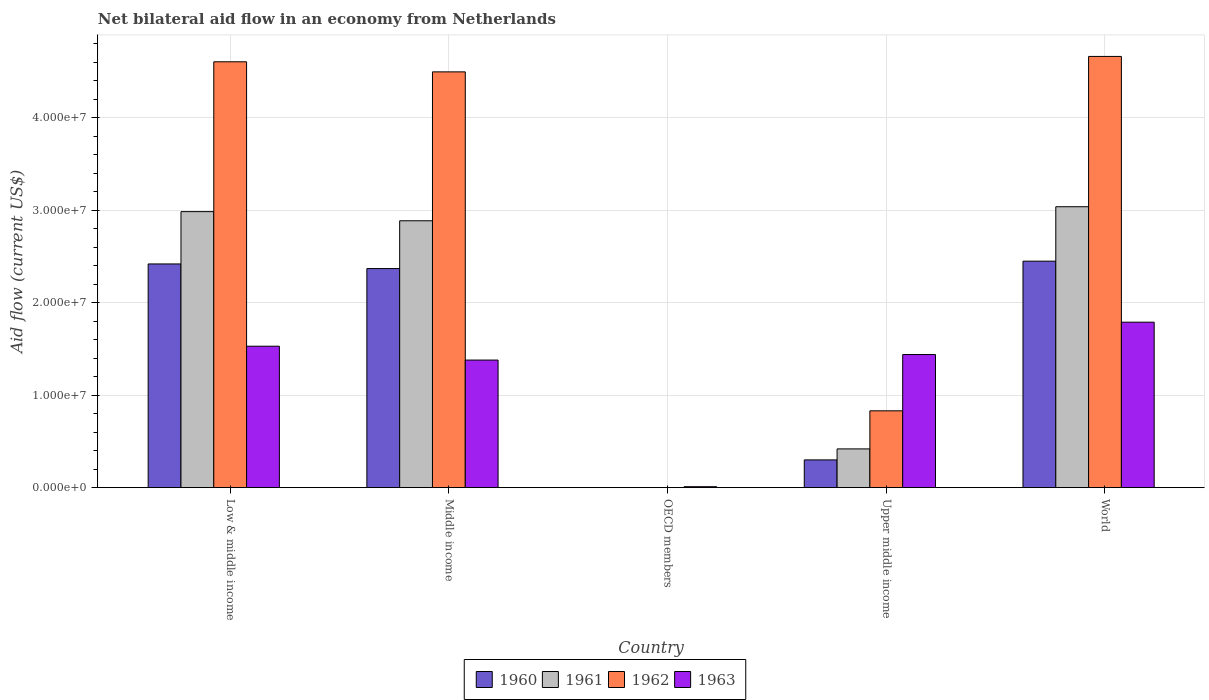Are the number of bars per tick equal to the number of legend labels?
Ensure brevity in your answer.  No. Are the number of bars on each tick of the X-axis equal?
Keep it short and to the point. No. How many bars are there on the 5th tick from the right?
Your response must be concise. 4. What is the label of the 2nd group of bars from the left?
Make the answer very short. Middle income. What is the net bilateral aid flow in 1960 in World?
Your answer should be compact. 2.45e+07. Across all countries, what is the maximum net bilateral aid flow in 1961?
Give a very brief answer. 3.04e+07. What is the total net bilateral aid flow in 1960 in the graph?
Offer a very short reply. 7.54e+07. What is the difference between the net bilateral aid flow in 1963 in OECD members and that in World?
Provide a short and direct response. -1.78e+07. What is the difference between the net bilateral aid flow in 1961 in Low & middle income and the net bilateral aid flow in 1962 in Middle income?
Make the answer very short. -1.51e+07. What is the average net bilateral aid flow in 1962 per country?
Your answer should be compact. 2.92e+07. What is the difference between the net bilateral aid flow of/in 1961 and net bilateral aid flow of/in 1960 in Middle income?
Your answer should be very brief. 5.17e+06. In how many countries, is the net bilateral aid flow in 1963 greater than 6000000 US$?
Offer a very short reply. 4. What is the ratio of the net bilateral aid flow in 1962 in Low & middle income to that in World?
Offer a very short reply. 0.99. Is the net bilateral aid flow in 1961 in Middle income less than that in World?
Give a very brief answer. Yes. What is the difference between the highest and the lowest net bilateral aid flow in 1962?
Your response must be concise. 4.66e+07. Is it the case that in every country, the sum of the net bilateral aid flow in 1960 and net bilateral aid flow in 1963 is greater than the net bilateral aid flow in 1962?
Provide a succinct answer. No. What is the difference between two consecutive major ticks on the Y-axis?
Your response must be concise. 1.00e+07. Does the graph contain any zero values?
Your answer should be compact. Yes. Does the graph contain grids?
Ensure brevity in your answer.  Yes. How many legend labels are there?
Make the answer very short. 4. What is the title of the graph?
Keep it short and to the point. Net bilateral aid flow in an economy from Netherlands. What is the Aid flow (current US$) in 1960 in Low & middle income?
Your answer should be very brief. 2.42e+07. What is the Aid flow (current US$) of 1961 in Low & middle income?
Ensure brevity in your answer.  2.99e+07. What is the Aid flow (current US$) of 1962 in Low & middle income?
Offer a terse response. 4.61e+07. What is the Aid flow (current US$) of 1963 in Low & middle income?
Make the answer very short. 1.53e+07. What is the Aid flow (current US$) of 1960 in Middle income?
Offer a terse response. 2.37e+07. What is the Aid flow (current US$) of 1961 in Middle income?
Give a very brief answer. 2.89e+07. What is the Aid flow (current US$) of 1962 in Middle income?
Offer a very short reply. 4.50e+07. What is the Aid flow (current US$) in 1963 in Middle income?
Provide a succinct answer. 1.38e+07. What is the Aid flow (current US$) of 1961 in OECD members?
Offer a terse response. 0. What is the Aid flow (current US$) of 1963 in OECD members?
Your response must be concise. 1.00e+05. What is the Aid flow (current US$) in 1960 in Upper middle income?
Your answer should be very brief. 3.00e+06. What is the Aid flow (current US$) in 1961 in Upper middle income?
Offer a terse response. 4.19e+06. What is the Aid flow (current US$) in 1962 in Upper middle income?
Keep it short and to the point. 8.31e+06. What is the Aid flow (current US$) in 1963 in Upper middle income?
Give a very brief answer. 1.44e+07. What is the Aid flow (current US$) in 1960 in World?
Your answer should be compact. 2.45e+07. What is the Aid flow (current US$) in 1961 in World?
Your answer should be compact. 3.04e+07. What is the Aid flow (current US$) in 1962 in World?
Your answer should be very brief. 4.66e+07. What is the Aid flow (current US$) of 1963 in World?
Your answer should be very brief. 1.79e+07. Across all countries, what is the maximum Aid flow (current US$) in 1960?
Offer a terse response. 2.45e+07. Across all countries, what is the maximum Aid flow (current US$) of 1961?
Your response must be concise. 3.04e+07. Across all countries, what is the maximum Aid flow (current US$) in 1962?
Offer a very short reply. 4.66e+07. Across all countries, what is the maximum Aid flow (current US$) in 1963?
Provide a short and direct response. 1.79e+07. Across all countries, what is the minimum Aid flow (current US$) of 1960?
Ensure brevity in your answer.  0. Across all countries, what is the minimum Aid flow (current US$) in 1961?
Offer a terse response. 0. Across all countries, what is the minimum Aid flow (current US$) of 1962?
Make the answer very short. 0. Across all countries, what is the minimum Aid flow (current US$) in 1963?
Keep it short and to the point. 1.00e+05. What is the total Aid flow (current US$) of 1960 in the graph?
Provide a short and direct response. 7.54e+07. What is the total Aid flow (current US$) in 1961 in the graph?
Provide a succinct answer. 9.33e+07. What is the total Aid flow (current US$) in 1962 in the graph?
Offer a terse response. 1.46e+08. What is the total Aid flow (current US$) of 1963 in the graph?
Your answer should be compact. 6.15e+07. What is the difference between the Aid flow (current US$) in 1960 in Low & middle income and that in Middle income?
Offer a terse response. 5.00e+05. What is the difference between the Aid flow (current US$) in 1961 in Low & middle income and that in Middle income?
Your answer should be compact. 9.90e+05. What is the difference between the Aid flow (current US$) of 1962 in Low & middle income and that in Middle income?
Give a very brief answer. 1.09e+06. What is the difference between the Aid flow (current US$) in 1963 in Low & middle income and that in Middle income?
Provide a short and direct response. 1.50e+06. What is the difference between the Aid flow (current US$) in 1963 in Low & middle income and that in OECD members?
Offer a very short reply. 1.52e+07. What is the difference between the Aid flow (current US$) of 1960 in Low & middle income and that in Upper middle income?
Give a very brief answer. 2.12e+07. What is the difference between the Aid flow (current US$) in 1961 in Low & middle income and that in Upper middle income?
Your response must be concise. 2.57e+07. What is the difference between the Aid flow (current US$) of 1962 in Low & middle income and that in Upper middle income?
Provide a succinct answer. 3.78e+07. What is the difference between the Aid flow (current US$) of 1961 in Low & middle income and that in World?
Your answer should be very brief. -5.30e+05. What is the difference between the Aid flow (current US$) of 1962 in Low & middle income and that in World?
Make the answer very short. -5.80e+05. What is the difference between the Aid flow (current US$) of 1963 in Low & middle income and that in World?
Make the answer very short. -2.60e+06. What is the difference between the Aid flow (current US$) in 1963 in Middle income and that in OECD members?
Offer a terse response. 1.37e+07. What is the difference between the Aid flow (current US$) of 1960 in Middle income and that in Upper middle income?
Your answer should be very brief. 2.07e+07. What is the difference between the Aid flow (current US$) of 1961 in Middle income and that in Upper middle income?
Your answer should be compact. 2.47e+07. What is the difference between the Aid flow (current US$) in 1962 in Middle income and that in Upper middle income?
Your answer should be compact. 3.67e+07. What is the difference between the Aid flow (current US$) in 1963 in Middle income and that in Upper middle income?
Your answer should be compact. -6.00e+05. What is the difference between the Aid flow (current US$) of 1960 in Middle income and that in World?
Keep it short and to the point. -8.00e+05. What is the difference between the Aid flow (current US$) in 1961 in Middle income and that in World?
Offer a terse response. -1.52e+06. What is the difference between the Aid flow (current US$) in 1962 in Middle income and that in World?
Ensure brevity in your answer.  -1.67e+06. What is the difference between the Aid flow (current US$) in 1963 in Middle income and that in World?
Your answer should be very brief. -4.10e+06. What is the difference between the Aid flow (current US$) of 1963 in OECD members and that in Upper middle income?
Ensure brevity in your answer.  -1.43e+07. What is the difference between the Aid flow (current US$) in 1963 in OECD members and that in World?
Give a very brief answer. -1.78e+07. What is the difference between the Aid flow (current US$) in 1960 in Upper middle income and that in World?
Give a very brief answer. -2.15e+07. What is the difference between the Aid flow (current US$) in 1961 in Upper middle income and that in World?
Ensure brevity in your answer.  -2.62e+07. What is the difference between the Aid flow (current US$) in 1962 in Upper middle income and that in World?
Your response must be concise. -3.83e+07. What is the difference between the Aid flow (current US$) of 1963 in Upper middle income and that in World?
Your answer should be compact. -3.50e+06. What is the difference between the Aid flow (current US$) of 1960 in Low & middle income and the Aid flow (current US$) of 1961 in Middle income?
Your answer should be compact. -4.67e+06. What is the difference between the Aid flow (current US$) in 1960 in Low & middle income and the Aid flow (current US$) in 1962 in Middle income?
Give a very brief answer. -2.08e+07. What is the difference between the Aid flow (current US$) in 1960 in Low & middle income and the Aid flow (current US$) in 1963 in Middle income?
Make the answer very short. 1.04e+07. What is the difference between the Aid flow (current US$) of 1961 in Low & middle income and the Aid flow (current US$) of 1962 in Middle income?
Provide a short and direct response. -1.51e+07. What is the difference between the Aid flow (current US$) in 1961 in Low & middle income and the Aid flow (current US$) in 1963 in Middle income?
Your answer should be very brief. 1.61e+07. What is the difference between the Aid flow (current US$) in 1962 in Low & middle income and the Aid flow (current US$) in 1963 in Middle income?
Your response must be concise. 3.23e+07. What is the difference between the Aid flow (current US$) in 1960 in Low & middle income and the Aid flow (current US$) in 1963 in OECD members?
Offer a very short reply. 2.41e+07. What is the difference between the Aid flow (current US$) in 1961 in Low & middle income and the Aid flow (current US$) in 1963 in OECD members?
Make the answer very short. 2.98e+07. What is the difference between the Aid flow (current US$) in 1962 in Low & middle income and the Aid flow (current US$) in 1963 in OECD members?
Keep it short and to the point. 4.60e+07. What is the difference between the Aid flow (current US$) of 1960 in Low & middle income and the Aid flow (current US$) of 1961 in Upper middle income?
Give a very brief answer. 2.00e+07. What is the difference between the Aid flow (current US$) in 1960 in Low & middle income and the Aid flow (current US$) in 1962 in Upper middle income?
Your response must be concise. 1.59e+07. What is the difference between the Aid flow (current US$) of 1960 in Low & middle income and the Aid flow (current US$) of 1963 in Upper middle income?
Give a very brief answer. 9.80e+06. What is the difference between the Aid flow (current US$) of 1961 in Low & middle income and the Aid flow (current US$) of 1962 in Upper middle income?
Offer a very short reply. 2.16e+07. What is the difference between the Aid flow (current US$) of 1961 in Low & middle income and the Aid flow (current US$) of 1963 in Upper middle income?
Make the answer very short. 1.55e+07. What is the difference between the Aid flow (current US$) of 1962 in Low & middle income and the Aid flow (current US$) of 1963 in Upper middle income?
Your answer should be very brief. 3.17e+07. What is the difference between the Aid flow (current US$) in 1960 in Low & middle income and the Aid flow (current US$) in 1961 in World?
Your answer should be very brief. -6.19e+06. What is the difference between the Aid flow (current US$) in 1960 in Low & middle income and the Aid flow (current US$) in 1962 in World?
Your response must be concise. -2.24e+07. What is the difference between the Aid flow (current US$) in 1960 in Low & middle income and the Aid flow (current US$) in 1963 in World?
Offer a very short reply. 6.30e+06. What is the difference between the Aid flow (current US$) of 1961 in Low & middle income and the Aid flow (current US$) of 1962 in World?
Your response must be concise. -1.68e+07. What is the difference between the Aid flow (current US$) in 1961 in Low & middle income and the Aid flow (current US$) in 1963 in World?
Keep it short and to the point. 1.20e+07. What is the difference between the Aid flow (current US$) in 1962 in Low & middle income and the Aid flow (current US$) in 1963 in World?
Provide a short and direct response. 2.82e+07. What is the difference between the Aid flow (current US$) in 1960 in Middle income and the Aid flow (current US$) in 1963 in OECD members?
Provide a succinct answer. 2.36e+07. What is the difference between the Aid flow (current US$) of 1961 in Middle income and the Aid flow (current US$) of 1963 in OECD members?
Offer a very short reply. 2.88e+07. What is the difference between the Aid flow (current US$) in 1962 in Middle income and the Aid flow (current US$) in 1963 in OECD members?
Your answer should be very brief. 4.49e+07. What is the difference between the Aid flow (current US$) of 1960 in Middle income and the Aid flow (current US$) of 1961 in Upper middle income?
Give a very brief answer. 1.95e+07. What is the difference between the Aid flow (current US$) in 1960 in Middle income and the Aid flow (current US$) in 1962 in Upper middle income?
Offer a very short reply. 1.54e+07. What is the difference between the Aid flow (current US$) of 1960 in Middle income and the Aid flow (current US$) of 1963 in Upper middle income?
Keep it short and to the point. 9.30e+06. What is the difference between the Aid flow (current US$) in 1961 in Middle income and the Aid flow (current US$) in 1962 in Upper middle income?
Ensure brevity in your answer.  2.06e+07. What is the difference between the Aid flow (current US$) in 1961 in Middle income and the Aid flow (current US$) in 1963 in Upper middle income?
Offer a terse response. 1.45e+07. What is the difference between the Aid flow (current US$) of 1962 in Middle income and the Aid flow (current US$) of 1963 in Upper middle income?
Your response must be concise. 3.06e+07. What is the difference between the Aid flow (current US$) in 1960 in Middle income and the Aid flow (current US$) in 1961 in World?
Offer a terse response. -6.69e+06. What is the difference between the Aid flow (current US$) in 1960 in Middle income and the Aid flow (current US$) in 1962 in World?
Make the answer very short. -2.30e+07. What is the difference between the Aid flow (current US$) in 1960 in Middle income and the Aid flow (current US$) in 1963 in World?
Give a very brief answer. 5.80e+06. What is the difference between the Aid flow (current US$) of 1961 in Middle income and the Aid flow (current US$) of 1962 in World?
Provide a short and direct response. -1.78e+07. What is the difference between the Aid flow (current US$) of 1961 in Middle income and the Aid flow (current US$) of 1963 in World?
Give a very brief answer. 1.10e+07. What is the difference between the Aid flow (current US$) of 1962 in Middle income and the Aid flow (current US$) of 1963 in World?
Provide a short and direct response. 2.71e+07. What is the difference between the Aid flow (current US$) of 1960 in Upper middle income and the Aid flow (current US$) of 1961 in World?
Provide a short and direct response. -2.74e+07. What is the difference between the Aid flow (current US$) in 1960 in Upper middle income and the Aid flow (current US$) in 1962 in World?
Your response must be concise. -4.36e+07. What is the difference between the Aid flow (current US$) in 1960 in Upper middle income and the Aid flow (current US$) in 1963 in World?
Your answer should be very brief. -1.49e+07. What is the difference between the Aid flow (current US$) in 1961 in Upper middle income and the Aid flow (current US$) in 1962 in World?
Keep it short and to the point. -4.25e+07. What is the difference between the Aid flow (current US$) of 1961 in Upper middle income and the Aid flow (current US$) of 1963 in World?
Give a very brief answer. -1.37e+07. What is the difference between the Aid flow (current US$) of 1962 in Upper middle income and the Aid flow (current US$) of 1963 in World?
Make the answer very short. -9.59e+06. What is the average Aid flow (current US$) of 1960 per country?
Your answer should be very brief. 1.51e+07. What is the average Aid flow (current US$) in 1961 per country?
Ensure brevity in your answer.  1.87e+07. What is the average Aid flow (current US$) of 1962 per country?
Provide a succinct answer. 2.92e+07. What is the average Aid flow (current US$) in 1963 per country?
Your answer should be very brief. 1.23e+07. What is the difference between the Aid flow (current US$) in 1960 and Aid flow (current US$) in 1961 in Low & middle income?
Offer a very short reply. -5.66e+06. What is the difference between the Aid flow (current US$) in 1960 and Aid flow (current US$) in 1962 in Low & middle income?
Your response must be concise. -2.19e+07. What is the difference between the Aid flow (current US$) in 1960 and Aid flow (current US$) in 1963 in Low & middle income?
Your answer should be very brief. 8.90e+06. What is the difference between the Aid flow (current US$) in 1961 and Aid flow (current US$) in 1962 in Low & middle income?
Provide a succinct answer. -1.62e+07. What is the difference between the Aid flow (current US$) of 1961 and Aid flow (current US$) of 1963 in Low & middle income?
Ensure brevity in your answer.  1.46e+07. What is the difference between the Aid flow (current US$) of 1962 and Aid flow (current US$) of 1963 in Low & middle income?
Give a very brief answer. 3.08e+07. What is the difference between the Aid flow (current US$) of 1960 and Aid flow (current US$) of 1961 in Middle income?
Ensure brevity in your answer.  -5.17e+06. What is the difference between the Aid flow (current US$) of 1960 and Aid flow (current US$) of 1962 in Middle income?
Offer a very short reply. -2.13e+07. What is the difference between the Aid flow (current US$) of 1960 and Aid flow (current US$) of 1963 in Middle income?
Your answer should be very brief. 9.90e+06. What is the difference between the Aid flow (current US$) of 1961 and Aid flow (current US$) of 1962 in Middle income?
Your answer should be very brief. -1.61e+07. What is the difference between the Aid flow (current US$) in 1961 and Aid flow (current US$) in 1963 in Middle income?
Give a very brief answer. 1.51e+07. What is the difference between the Aid flow (current US$) of 1962 and Aid flow (current US$) of 1963 in Middle income?
Offer a terse response. 3.12e+07. What is the difference between the Aid flow (current US$) in 1960 and Aid flow (current US$) in 1961 in Upper middle income?
Offer a terse response. -1.19e+06. What is the difference between the Aid flow (current US$) in 1960 and Aid flow (current US$) in 1962 in Upper middle income?
Make the answer very short. -5.31e+06. What is the difference between the Aid flow (current US$) of 1960 and Aid flow (current US$) of 1963 in Upper middle income?
Ensure brevity in your answer.  -1.14e+07. What is the difference between the Aid flow (current US$) of 1961 and Aid flow (current US$) of 1962 in Upper middle income?
Give a very brief answer. -4.12e+06. What is the difference between the Aid flow (current US$) in 1961 and Aid flow (current US$) in 1963 in Upper middle income?
Keep it short and to the point. -1.02e+07. What is the difference between the Aid flow (current US$) in 1962 and Aid flow (current US$) in 1963 in Upper middle income?
Your response must be concise. -6.09e+06. What is the difference between the Aid flow (current US$) in 1960 and Aid flow (current US$) in 1961 in World?
Provide a succinct answer. -5.89e+06. What is the difference between the Aid flow (current US$) of 1960 and Aid flow (current US$) of 1962 in World?
Offer a very short reply. -2.22e+07. What is the difference between the Aid flow (current US$) of 1960 and Aid flow (current US$) of 1963 in World?
Your answer should be compact. 6.60e+06. What is the difference between the Aid flow (current US$) in 1961 and Aid flow (current US$) in 1962 in World?
Ensure brevity in your answer.  -1.63e+07. What is the difference between the Aid flow (current US$) in 1961 and Aid flow (current US$) in 1963 in World?
Keep it short and to the point. 1.25e+07. What is the difference between the Aid flow (current US$) of 1962 and Aid flow (current US$) of 1963 in World?
Your answer should be compact. 2.88e+07. What is the ratio of the Aid flow (current US$) in 1960 in Low & middle income to that in Middle income?
Your answer should be compact. 1.02. What is the ratio of the Aid flow (current US$) in 1961 in Low & middle income to that in Middle income?
Keep it short and to the point. 1.03. What is the ratio of the Aid flow (current US$) in 1962 in Low & middle income to that in Middle income?
Give a very brief answer. 1.02. What is the ratio of the Aid flow (current US$) of 1963 in Low & middle income to that in Middle income?
Give a very brief answer. 1.11. What is the ratio of the Aid flow (current US$) in 1963 in Low & middle income to that in OECD members?
Your response must be concise. 153. What is the ratio of the Aid flow (current US$) of 1960 in Low & middle income to that in Upper middle income?
Make the answer very short. 8.07. What is the ratio of the Aid flow (current US$) of 1961 in Low & middle income to that in Upper middle income?
Offer a terse response. 7.13. What is the ratio of the Aid flow (current US$) of 1962 in Low & middle income to that in Upper middle income?
Your answer should be compact. 5.54. What is the ratio of the Aid flow (current US$) in 1961 in Low & middle income to that in World?
Keep it short and to the point. 0.98. What is the ratio of the Aid flow (current US$) of 1962 in Low & middle income to that in World?
Keep it short and to the point. 0.99. What is the ratio of the Aid flow (current US$) of 1963 in Low & middle income to that in World?
Give a very brief answer. 0.85. What is the ratio of the Aid flow (current US$) of 1963 in Middle income to that in OECD members?
Provide a succinct answer. 138. What is the ratio of the Aid flow (current US$) of 1960 in Middle income to that in Upper middle income?
Make the answer very short. 7.9. What is the ratio of the Aid flow (current US$) of 1961 in Middle income to that in Upper middle income?
Your answer should be very brief. 6.89. What is the ratio of the Aid flow (current US$) in 1962 in Middle income to that in Upper middle income?
Provide a short and direct response. 5.41. What is the ratio of the Aid flow (current US$) of 1963 in Middle income to that in Upper middle income?
Provide a succinct answer. 0.96. What is the ratio of the Aid flow (current US$) in 1960 in Middle income to that in World?
Give a very brief answer. 0.97. What is the ratio of the Aid flow (current US$) of 1961 in Middle income to that in World?
Provide a short and direct response. 0.95. What is the ratio of the Aid flow (current US$) in 1962 in Middle income to that in World?
Provide a succinct answer. 0.96. What is the ratio of the Aid flow (current US$) in 1963 in Middle income to that in World?
Your answer should be compact. 0.77. What is the ratio of the Aid flow (current US$) in 1963 in OECD members to that in Upper middle income?
Provide a short and direct response. 0.01. What is the ratio of the Aid flow (current US$) in 1963 in OECD members to that in World?
Your answer should be very brief. 0.01. What is the ratio of the Aid flow (current US$) of 1960 in Upper middle income to that in World?
Offer a terse response. 0.12. What is the ratio of the Aid flow (current US$) of 1961 in Upper middle income to that in World?
Provide a succinct answer. 0.14. What is the ratio of the Aid flow (current US$) of 1962 in Upper middle income to that in World?
Provide a short and direct response. 0.18. What is the ratio of the Aid flow (current US$) in 1963 in Upper middle income to that in World?
Provide a succinct answer. 0.8. What is the difference between the highest and the second highest Aid flow (current US$) in 1961?
Your answer should be compact. 5.30e+05. What is the difference between the highest and the second highest Aid flow (current US$) in 1962?
Your answer should be very brief. 5.80e+05. What is the difference between the highest and the second highest Aid flow (current US$) of 1963?
Offer a terse response. 2.60e+06. What is the difference between the highest and the lowest Aid flow (current US$) in 1960?
Your answer should be very brief. 2.45e+07. What is the difference between the highest and the lowest Aid flow (current US$) of 1961?
Offer a very short reply. 3.04e+07. What is the difference between the highest and the lowest Aid flow (current US$) in 1962?
Your answer should be very brief. 4.66e+07. What is the difference between the highest and the lowest Aid flow (current US$) of 1963?
Offer a very short reply. 1.78e+07. 